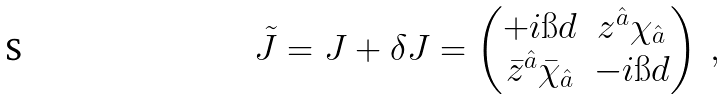<formula> <loc_0><loc_0><loc_500><loc_500>\tilde { J } = J + \delta J = \begin{pmatrix} + i \i d & z ^ { \hat { a } } \chi _ { \hat { a } } \\ \bar { z } ^ { \hat { a } } \bar { \chi } _ { \hat { a } } & - i \i d \end{pmatrix} \ ,</formula> 